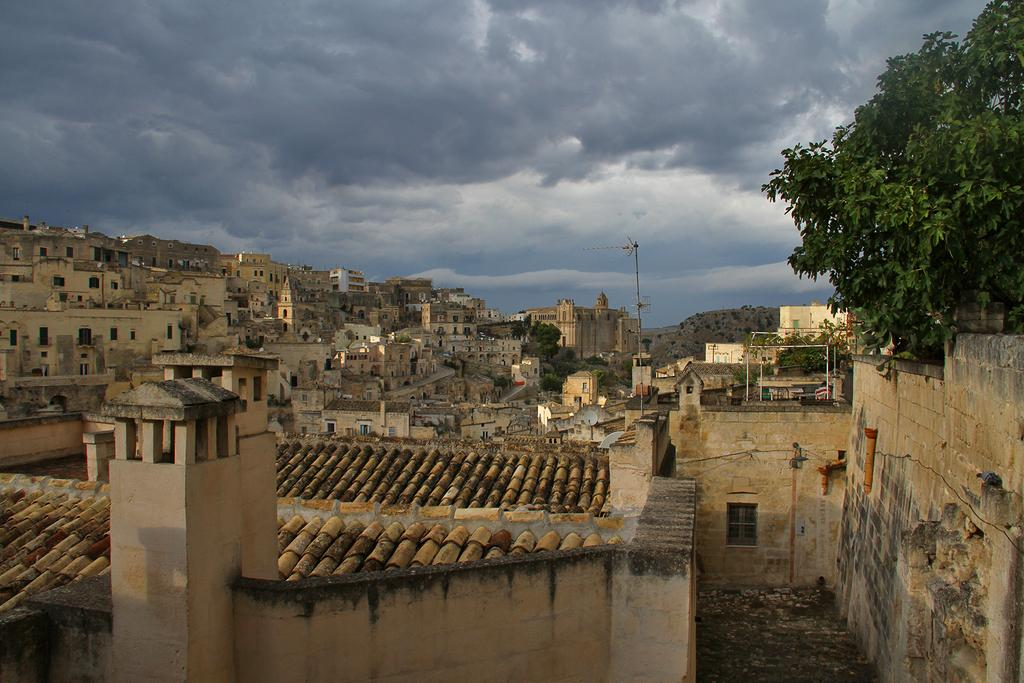What type of structures can be seen in the image? There are many buildings in the image. What other elements can be seen in the image besides buildings? There are trees in the image. How would you describe the sky in the image? The sky is cloudy in the image. Can you hear a song being sung by the trees in the image? There is no indication in the image that the trees are singing a song, as trees do not have the ability to sing. 